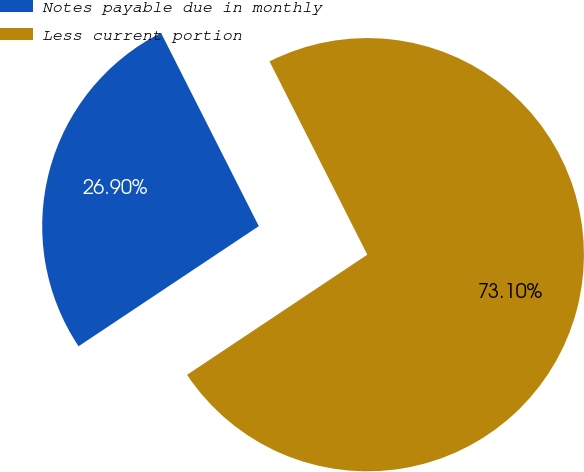<chart> <loc_0><loc_0><loc_500><loc_500><pie_chart><fcel>Notes payable due in monthly<fcel>Less current portion<nl><fcel>26.9%<fcel>73.1%<nl></chart> 